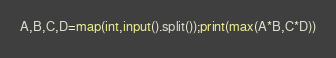Convert code to text. <code><loc_0><loc_0><loc_500><loc_500><_Python_>A,B,C,D=map(int,input().split());print(max(A*B,C*D))</code> 